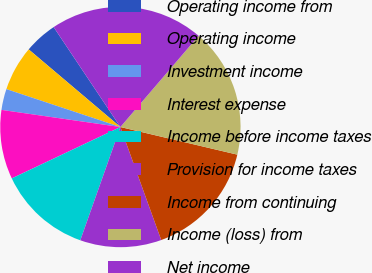<chart> <loc_0><loc_0><loc_500><loc_500><pie_chart><fcel>Operating income from<fcel>Operating income<fcel>Investment income<fcel>Interest expense<fcel>Income before income taxes<fcel>Provision for income taxes<fcel>Income from continuing<fcel>Income (loss) from<fcel>Net income<nl><fcel>4.45%<fcel>6.07%<fcel>2.83%<fcel>9.31%<fcel>12.55%<fcel>10.93%<fcel>15.79%<fcel>17.41%<fcel>20.65%<nl></chart> 